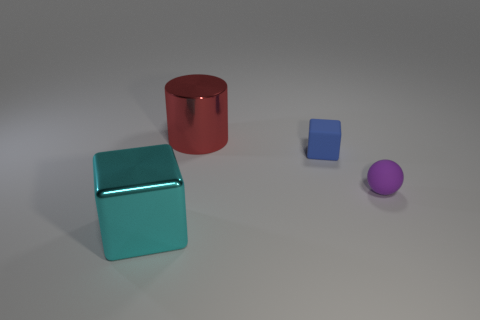Subtract all green blocks. Subtract all brown spheres. How many blocks are left? 2 Add 4 metallic blocks. How many objects exist? 8 Subtract all spheres. How many objects are left? 3 Subtract 0 yellow cylinders. How many objects are left? 4 Subtract all red shiny objects. Subtract all tiny purple things. How many objects are left? 2 Add 2 cyan metallic objects. How many cyan metallic objects are left? 3 Add 2 small matte objects. How many small matte objects exist? 4 